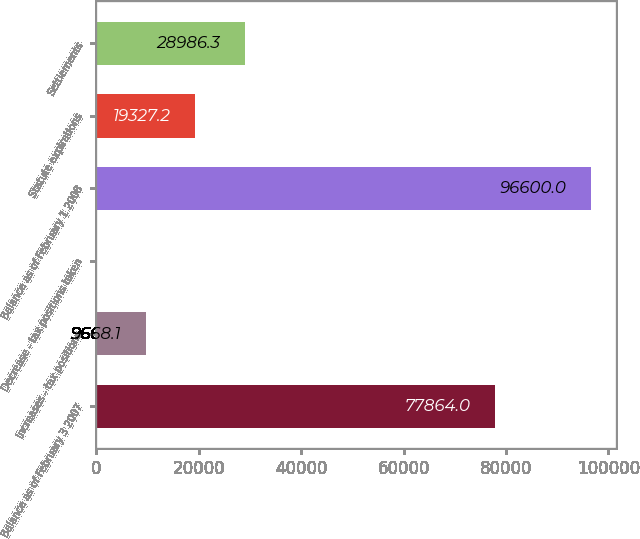<chart> <loc_0><loc_0><loc_500><loc_500><bar_chart><fcel>Balance as of February 3 2007<fcel>Increases - tax positions<fcel>Decrease - tax positions taken<fcel>Balance as of February 1 2008<fcel>Statute expirations<fcel>Settlements<nl><fcel>77864<fcel>9668.1<fcel>9<fcel>96600<fcel>19327.2<fcel>28986.3<nl></chart> 